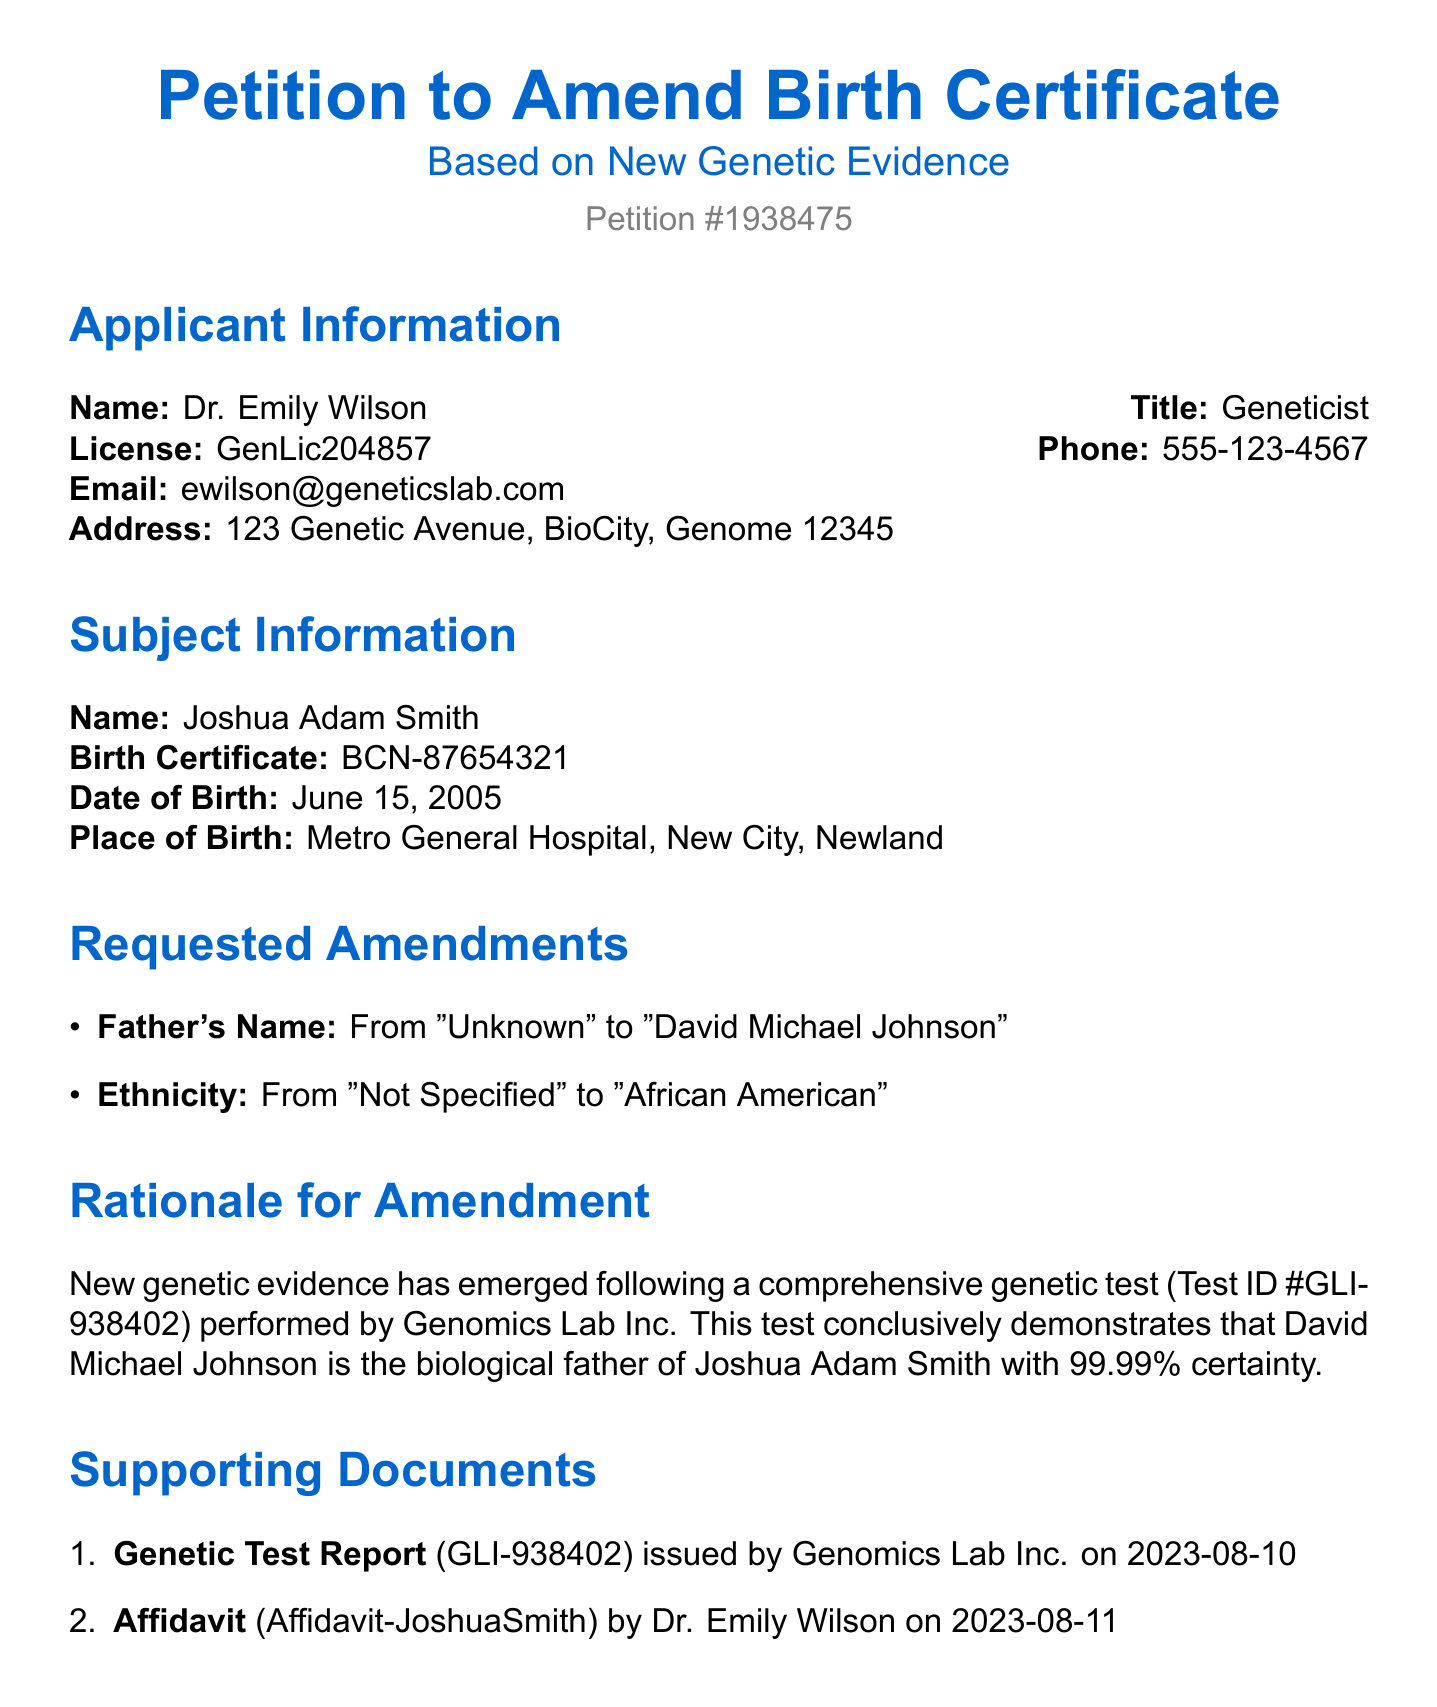What is the name of the applicant? The applicant's name is stated in the document under Applicant Information.
Answer: Dr. Emily Wilson What is the title of the applicant? The title is provided alongside the applicant's name in the document.
Answer: Geneticist What is the petition number? The petition number is prominently displayed in the document for reference.
Answer: Petition #1938475 What is the date of birth of Joshua Adam Smith? This information is listed under Subject Information in the document.
Answer: June 15, 2005 What is the test ID of the genetic test? The test ID is mentioned in the section Rationale for Amendment to support the claims made.
Answer: GLI-938402 What change is requested for Joshua Adam Smith's father's name? The requested amendment is noted in the Requested Amendments section of the document.
Answer: From "Unknown" to "David Michael Johnson" What is the certainty percentage of the genetic test? This percentage is provided in the Rationale for Amendment, indicating the confidence level of the results.
Answer: 99.99% What organization issued the Genetic Test Report? The name of the organization is cited in the Supporting Documents section of the document.
Answer: Genomics Lab Inc What is the significance of the affidavit included in the supporting documents? Its importance is indicated in the document as supporting evidence for the petition.
Answer: To substantiate the petition 